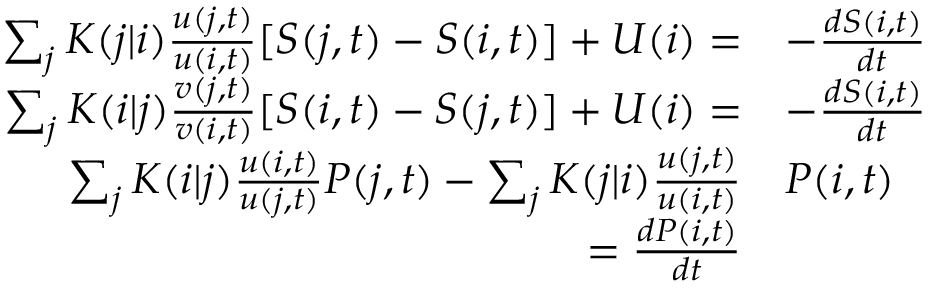<formula> <loc_0><loc_0><loc_500><loc_500>\begin{array} { r l } { \sum _ { j } K ( j | i ) \frac { u ( j , t ) } { u ( i , t ) } [ S ( j , t ) - S ( i , t ) ] + U ( i ) = } & { - \frac { d S ( i , t ) } { d t } } \\ { \sum _ { j } K ( i | j ) \frac { v ( j , t ) } { v ( i , t ) } [ S ( i , t ) - S ( j , t ) ] + U ( i ) = } & { - \frac { d S ( i , t ) } { d t } } \\ { \sum _ { j } K ( i | j ) \frac { u ( i , t ) } { u ( j , t ) } P ( j , t ) - \sum _ { j } K ( j | i ) \frac { u ( j , t ) } { u ( i , t ) } } & { P ( i , t ) } \\ { = \frac { d P ( i , t ) } { d t } } \end{array}</formula> 